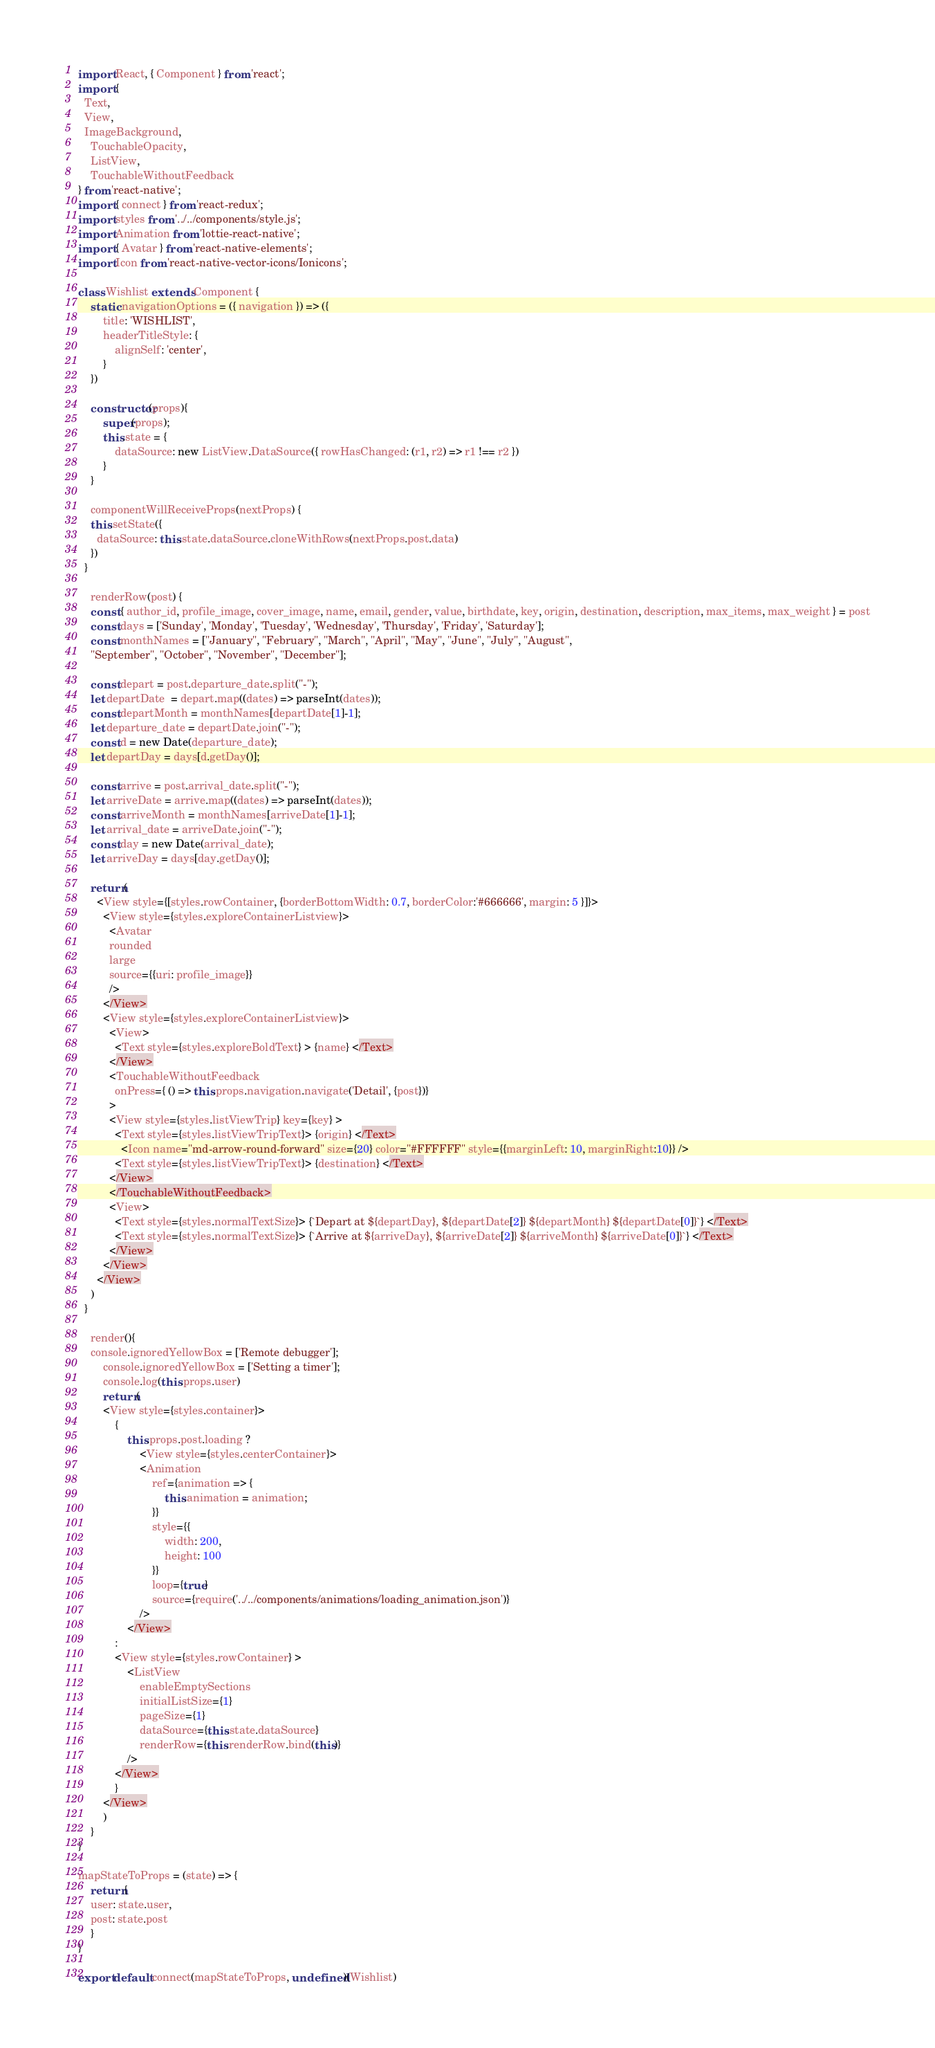Convert code to text. <code><loc_0><loc_0><loc_500><loc_500><_JavaScript_>import React, { Component } from 'react';
import {
  Text,
  View,
  ImageBackground,
	TouchableOpacity,
	ListView,
	TouchableWithoutFeedback
} from 'react-native';
import { connect } from 'react-redux';
import styles from '../../components/style.js';
import Animation from 'lottie-react-native';
import { Avatar } from 'react-native-elements';
import Icon from 'react-native-vector-icons/Ionicons';

class Wishlist extends Component {
	static navigationOptions = ({ navigation }) => ({
		title: 'WISHLIST',
		headerTitleStyle: {
			alignSelf: 'center',
		}
	})

	constructor(props){
		super(props);
		this.state = {
			dataSource: new ListView.DataSource({ rowHasChanged: (r1, r2) => r1 !== r2 })			
		}
	}

	componentWillReceiveProps(nextProps) {
    this.setState({
      dataSource: this.state.dataSource.cloneWithRows(nextProps.post.data)
    })
  }	

	renderRow(post) {
    const { author_id, profile_image, cover_image, name, email, gender, value, birthdate, key, origin, destination, description, max_items, max_weight } = post
    const days = ['Sunday', 'Monday', 'Tuesday', 'Wednesday', 'Thursday', 'Friday', 'Saturday'];    
    const monthNames = ["January", "February", "March", "April", "May", "June", "July", "August",
    "September", "October", "November", "December"];

    const depart = post.departure_date.split("-");
    let departDate  = depart.map((dates) => parseInt(dates));
    const departMonth = monthNames[departDate[1]-1];
    let departure_date = departDate.join("-");
    const d = new Date(departure_date);
    let departDay = days[d.getDay()];

    const arrive = post.arrival_date.split("-");
    let arriveDate = arrive.map((dates) => parseInt(dates));
    const arriveMonth = monthNames[arriveDate[1]-1];
    let arrival_date = arriveDate.join("-");
    const day = new Date(arrival_date);
    let arriveDay = days[day.getDay()];

    return(
      <View style={[styles.rowContainer, {borderBottomWidth: 0.7, borderColor:'#666666', margin: 5 }]}>
        <View style={styles.exploreContainerListview}>
          <Avatar 
          rounded
          large
          source={{uri: profile_image}}
          />
        </View>
        <View style={styles.exploreContainerListview}>
          <View>
            <Text style={styles.exploreBoldText} > {name} </Text>
          </View>
          <TouchableWithoutFeedback
            onPress={ () => this.props.navigation.navigate('Detail', {post})}
          >
          <View style={styles.listViewTrip} key={key} >
            <Text style={styles.listViewTripText}> {origin} </Text>
              <Icon name="md-arrow-round-forward" size={20} color="#FFFFFF" style={{marginLeft: 10, marginRight:10}} />
            <Text style={styles.listViewTripText}> {destination} </Text>
          </View>
          </TouchableWithoutFeedback>
          <View>
            <Text style={styles.normalTextSize}> {`Depart at ${departDay}, ${departDate[2]} ${departMonth} ${departDate[0]}`} </Text>
            <Text style={styles.normalTextSize}> {`Arrive at ${arriveDay}, ${arriveDate[2]} ${arriveMonth} ${arriveDate[0]}`} </Text>
          </View>
        </View>
      </View>
    )
  }

	render(){
  	console.ignoredYellowBox = ['Remote debugger'];
		console.ignoredYellowBox = ['Setting a timer'];
		console.log(this.props.user)
		return(
		<View style={styles.container}>
			{
				this.props.post.loading ?
					<View style={styles.centerContainer}>
					<Animation
						ref={animation => {
							this.animation = animation;
						}}
						style={{
							width: 200,
							height: 100
						}}
						loop={true}
						source={require('../../components/animations/loading_animation.json')}
					/>
				</View>
			:
			<View style={styles.rowContainer} >
				<ListView
					enableEmptySections
					initialListSize={1}
					pageSize={1}
					dataSource={this.state.dataSource}
					renderRow={this.renderRow.bind(this)}
				/>
			</View>
			}
		</View>
		)
	}
}

mapStateToProps = (state) => {
	return{
	user: state.user,
	post: state.post
	}
}

export default connect(mapStateToProps, undefined)(Wishlist)</code> 